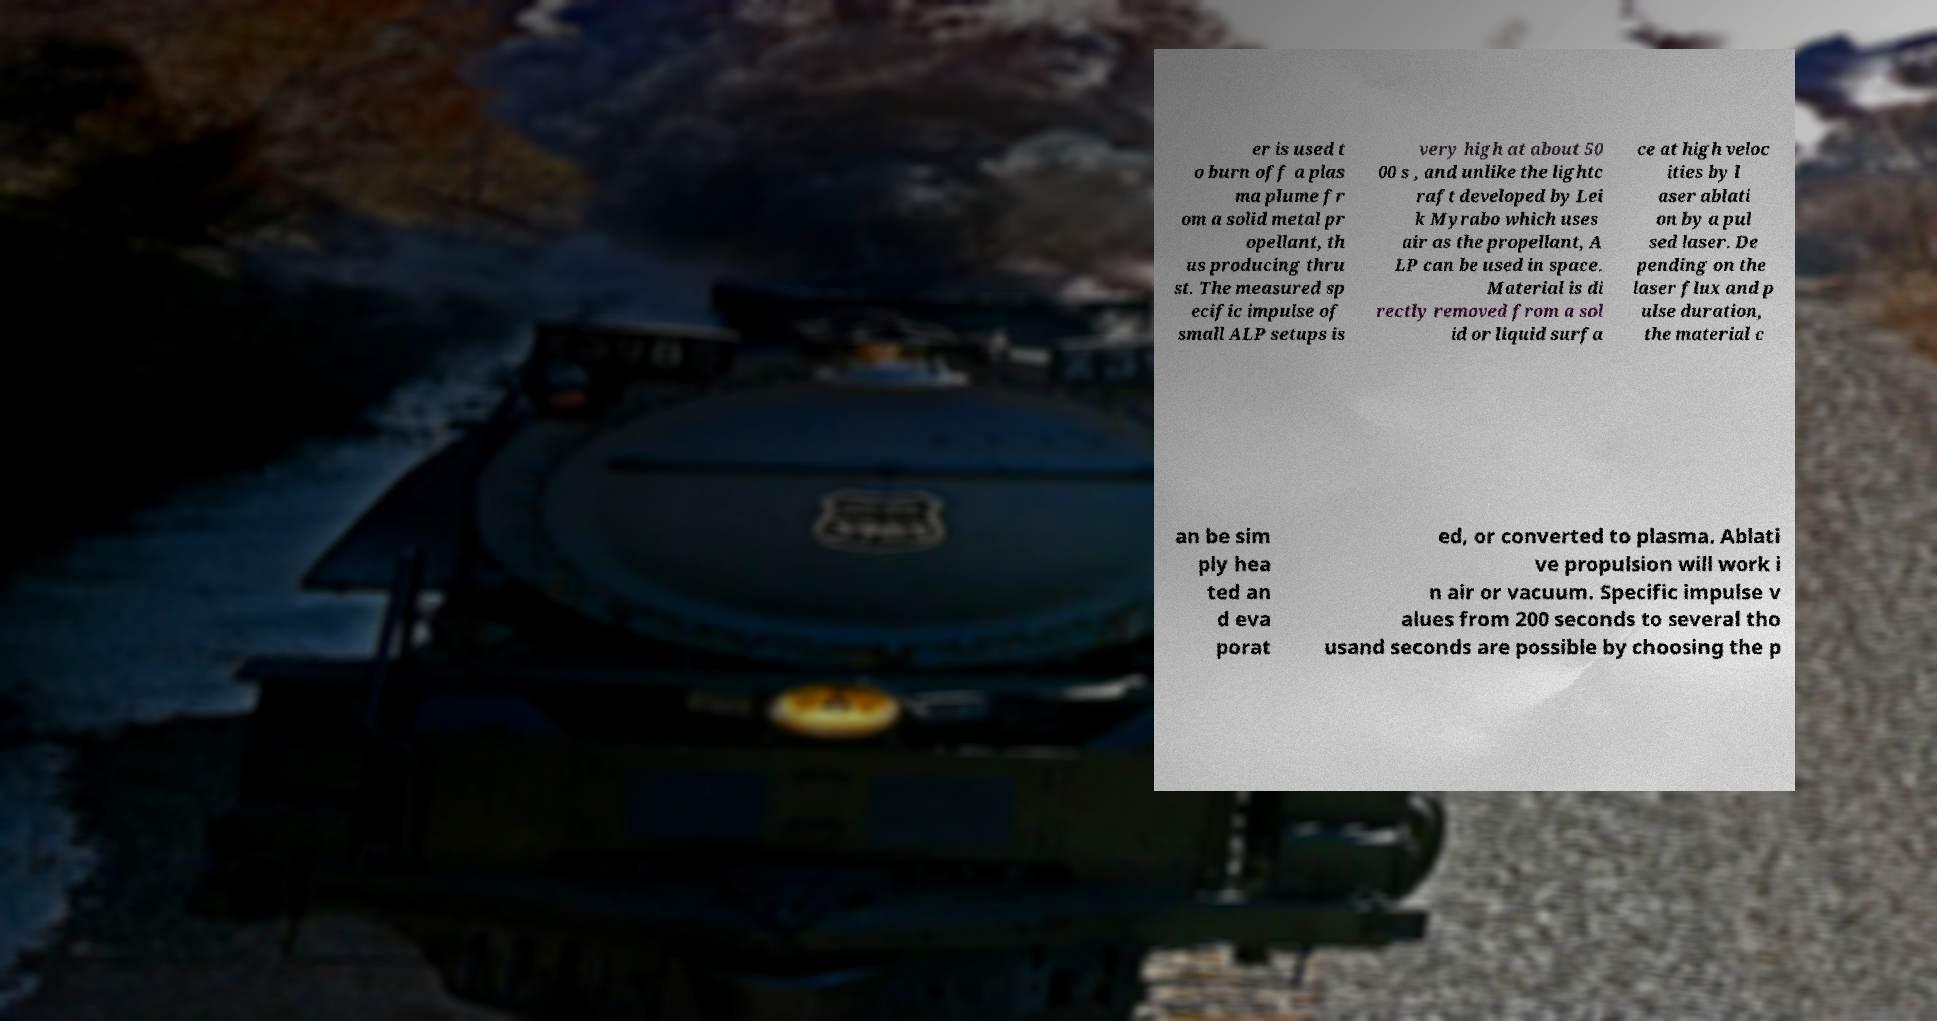There's text embedded in this image that I need extracted. Can you transcribe it verbatim? er is used t o burn off a plas ma plume fr om a solid metal pr opellant, th us producing thru st. The measured sp ecific impulse of small ALP setups is very high at about 50 00 s , and unlike the lightc raft developed by Lei k Myrabo which uses air as the propellant, A LP can be used in space. Material is di rectly removed from a sol id or liquid surfa ce at high veloc ities by l aser ablati on by a pul sed laser. De pending on the laser flux and p ulse duration, the material c an be sim ply hea ted an d eva porat ed, or converted to plasma. Ablati ve propulsion will work i n air or vacuum. Specific impulse v alues from 200 seconds to several tho usand seconds are possible by choosing the p 